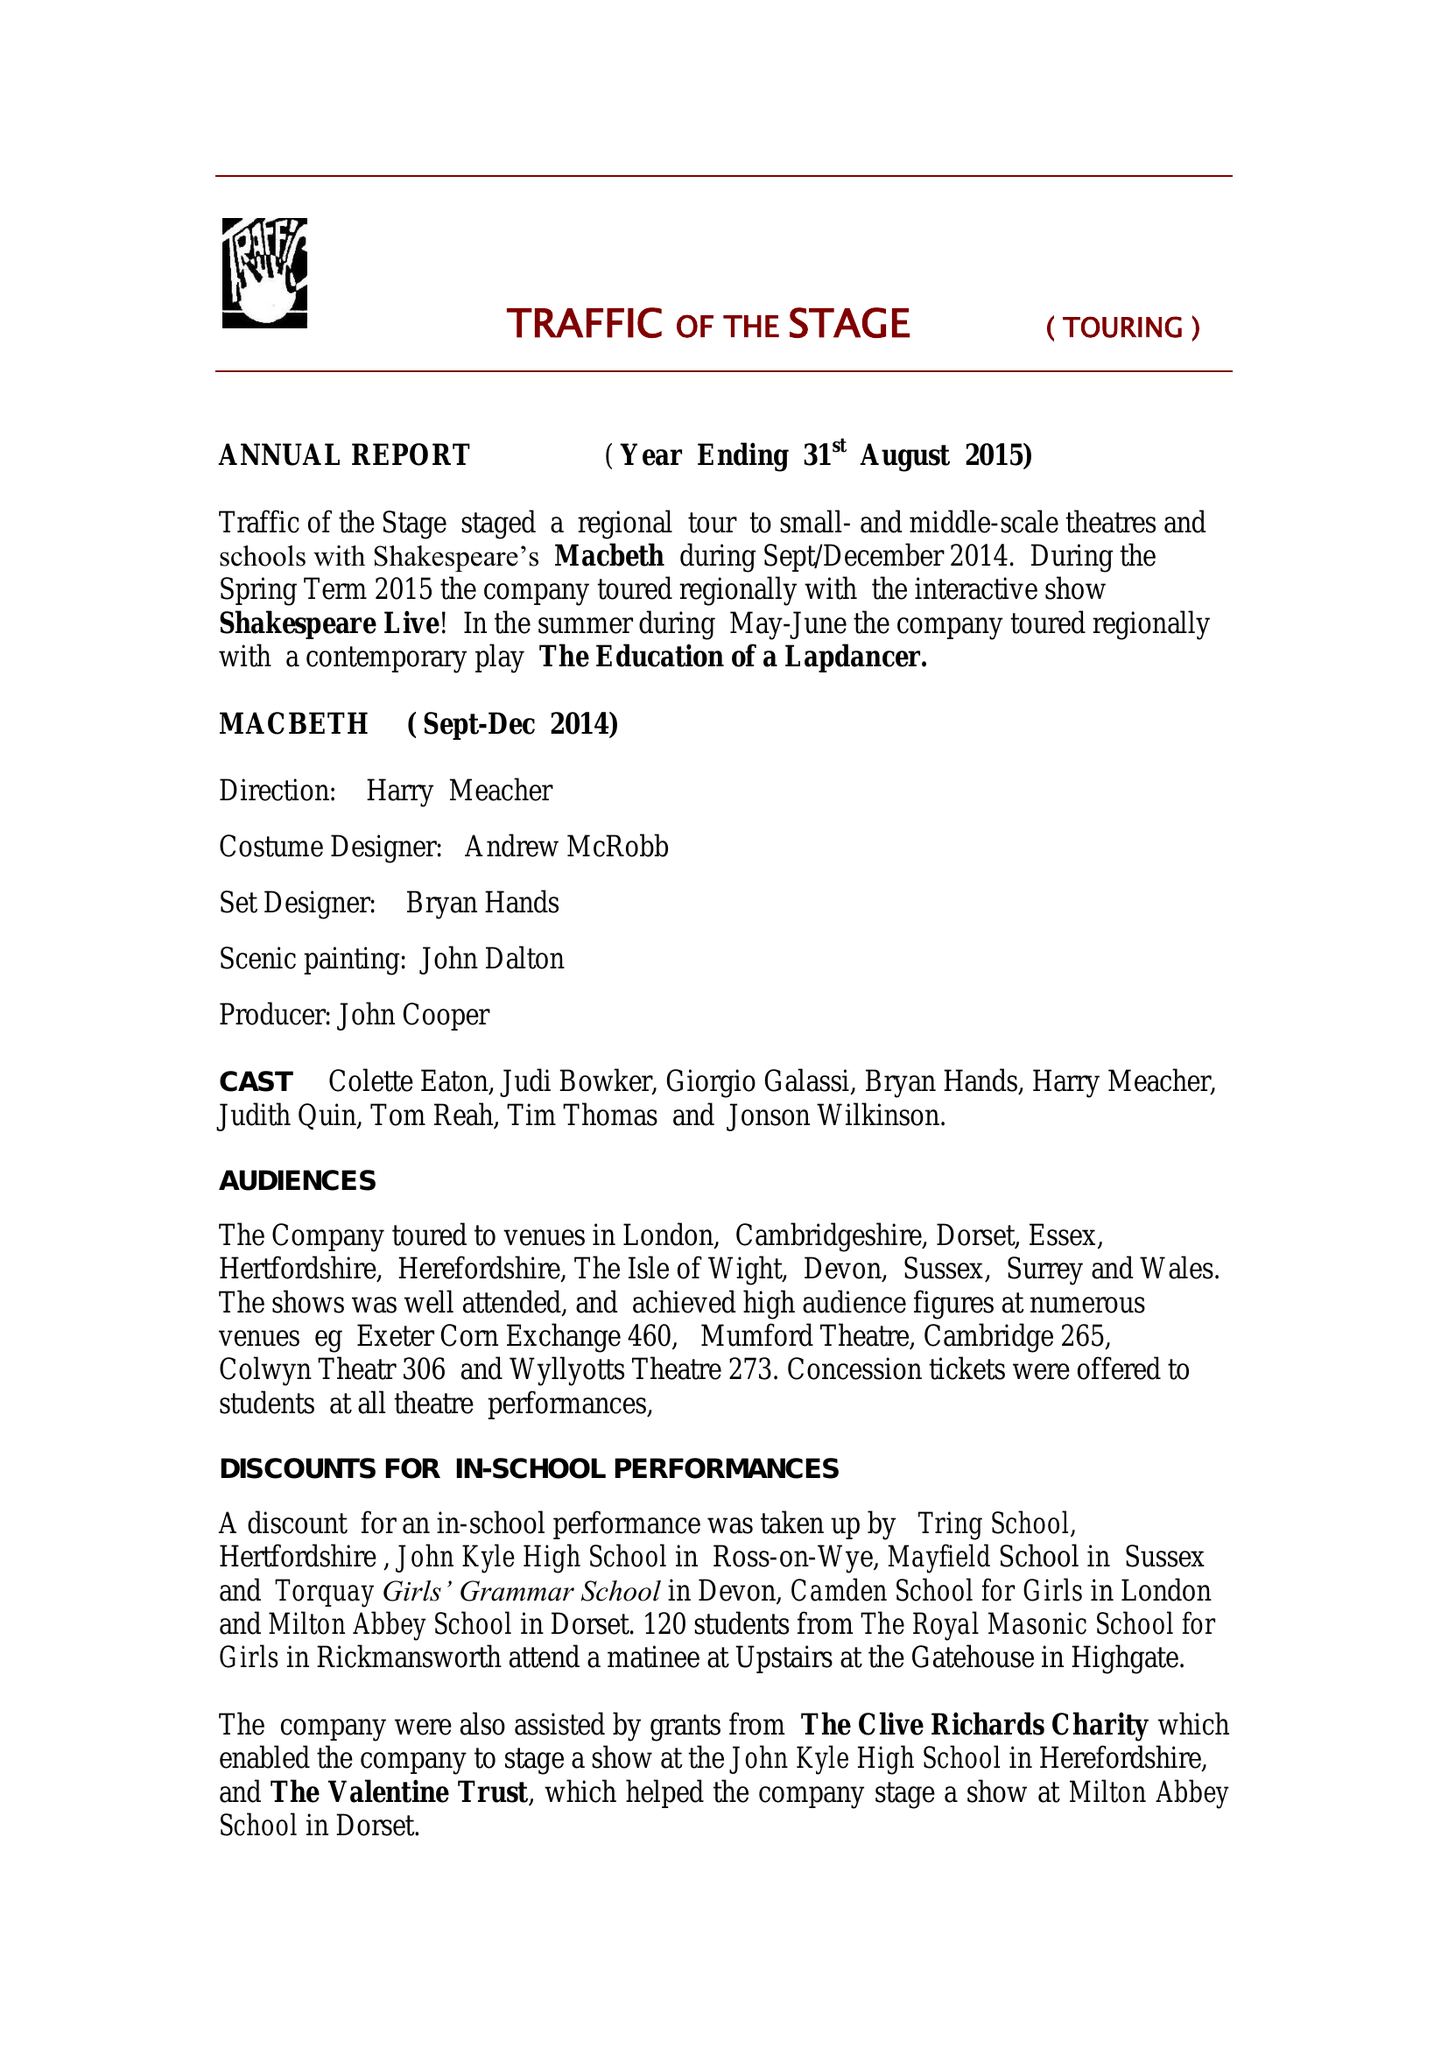What is the value for the address__post_town?
Answer the question using a single word or phrase. TORRINGTON 